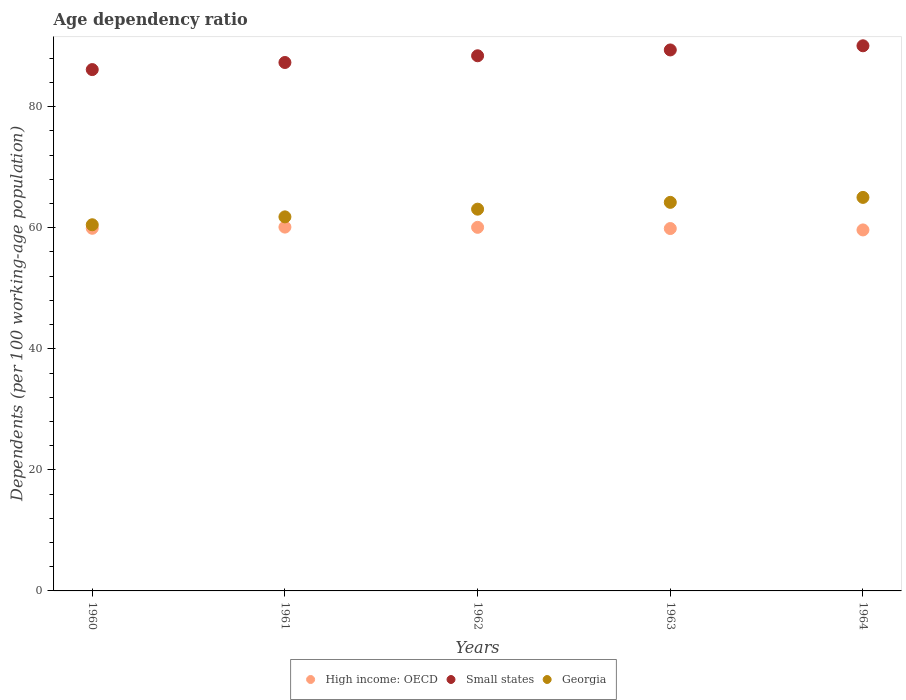Is the number of dotlines equal to the number of legend labels?
Your answer should be compact. Yes. What is the age dependency ratio in in Georgia in 1961?
Ensure brevity in your answer.  61.8. Across all years, what is the maximum age dependency ratio in in High income: OECD?
Offer a terse response. 60.11. Across all years, what is the minimum age dependency ratio in in Small states?
Your answer should be very brief. 86.14. In which year was the age dependency ratio in in Georgia maximum?
Ensure brevity in your answer.  1964. In which year was the age dependency ratio in in High income: OECD minimum?
Your response must be concise. 1964. What is the total age dependency ratio in in Small states in the graph?
Your answer should be very brief. 441.31. What is the difference between the age dependency ratio in in High income: OECD in 1963 and that in 1964?
Your answer should be compact. 0.23. What is the difference between the age dependency ratio in in Georgia in 1961 and the age dependency ratio in in Small states in 1964?
Your answer should be compact. -28.27. What is the average age dependency ratio in in Small states per year?
Offer a terse response. 88.26. In the year 1964, what is the difference between the age dependency ratio in in High income: OECD and age dependency ratio in in Small states?
Offer a very short reply. -30.43. What is the ratio of the age dependency ratio in in Small states in 1961 to that in 1962?
Keep it short and to the point. 0.99. What is the difference between the highest and the second highest age dependency ratio in in Small states?
Offer a terse response. 0.69. What is the difference between the highest and the lowest age dependency ratio in in High income: OECD?
Ensure brevity in your answer.  0.47. In how many years, is the age dependency ratio in in High income: OECD greater than the average age dependency ratio in in High income: OECD taken over all years?
Your answer should be very brief. 2. Is it the case that in every year, the sum of the age dependency ratio in in High income: OECD and age dependency ratio in in Small states  is greater than the age dependency ratio in in Georgia?
Your answer should be very brief. Yes. Is the age dependency ratio in in High income: OECD strictly less than the age dependency ratio in in Georgia over the years?
Your answer should be very brief. Yes. How many dotlines are there?
Provide a succinct answer. 3. How many years are there in the graph?
Your response must be concise. 5. What is the title of the graph?
Offer a terse response. Age dependency ratio. What is the label or title of the X-axis?
Your response must be concise. Years. What is the label or title of the Y-axis?
Offer a terse response. Dependents (per 100 working-age population). What is the Dependents (per 100 working-age population) in High income: OECD in 1960?
Keep it short and to the point. 59.92. What is the Dependents (per 100 working-age population) in Small states in 1960?
Give a very brief answer. 86.14. What is the Dependents (per 100 working-age population) of Georgia in 1960?
Your response must be concise. 60.5. What is the Dependents (per 100 working-age population) in High income: OECD in 1961?
Offer a terse response. 60.11. What is the Dependents (per 100 working-age population) of Small states in 1961?
Offer a terse response. 87.31. What is the Dependents (per 100 working-age population) of Georgia in 1961?
Keep it short and to the point. 61.8. What is the Dependents (per 100 working-age population) in High income: OECD in 1962?
Your answer should be very brief. 60.07. What is the Dependents (per 100 working-age population) of Small states in 1962?
Provide a succinct answer. 88.42. What is the Dependents (per 100 working-age population) of Georgia in 1962?
Make the answer very short. 63.07. What is the Dependents (per 100 working-age population) of High income: OECD in 1963?
Offer a very short reply. 59.87. What is the Dependents (per 100 working-age population) in Small states in 1963?
Give a very brief answer. 89.38. What is the Dependents (per 100 working-age population) in Georgia in 1963?
Your answer should be compact. 64.2. What is the Dependents (per 100 working-age population) in High income: OECD in 1964?
Make the answer very short. 59.64. What is the Dependents (per 100 working-age population) of Small states in 1964?
Offer a very short reply. 90.07. What is the Dependents (per 100 working-age population) of Georgia in 1964?
Provide a succinct answer. 65.02. Across all years, what is the maximum Dependents (per 100 working-age population) in High income: OECD?
Provide a succinct answer. 60.11. Across all years, what is the maximum Dependents (per 100 working-age population) in Small states?
Give a very brief answer. 90.07. Across all years, what is the maximum Dependents (per 100 working-age population) of Georgia?
Offer a terse response. 65.02. Across all years, what is the minimum Dependents (per 100 working-age population) in High income: OECD?
Make the answer very short. 59.64. Across all years, what is the minimum Dependents (per 100 working-age population) of Small states?
Your answer should be very brief. 86.14. Across all years, what is the minimum Dependents (per 100 working-age population) of Georgia?
Provide a succinct answer. 60.5. What is the total Dependents (per 100 working-age population) in High income: OECD in the graph?
Offer a terse response. 299.62. What is the total Dependents (per 100 working-age population) of Small states in the graph?
Your answer should be very brief. 441.31. What is the total Dependents (per 100 working-age population) of Georgia in the graph?
Your response must be concise. 314.59. What is the difference between the Dependents (per 100 working-age population) of High income: OECD in 1960 and that in 1961?
Offer a very short reply. -0.2. What is the difference between the Dependents (per 100 working-age population) in Small states in 1960 and that in 1961?
Keep it short and to the point. -1.17. What is the difference between the Dependents (per 100 working-age population) of Georgia in 1960 and that in 1961?
Offer a very short reply. -1.3. What is the difference between the Dependents (per 100 working-age population) in High income: OECD in 1960 and that in 1962?
Keep it short and to the point. -0.16. What is the difference between the Dependents (per 100 working-age population) of Small states in 1960 and that in 1962?
Your response must be concise. -2.28. What is the difference between the Dependents (per 100 working-age population) of Georgia in 1960 and that in 1962?
Your answer should be compact. -2.58. What is the difference between the Dependents (per 100 working-age population) in High income: OECD in 1960 and that in 1963?
Make the answer very short. 0.04. What is the difference between the Dependents (per 100 working-age population) of Small states in 1960 and that in 1963?
Offer a terse response. -3.25. What is the difference between the Dependents (per 100 working-age population) in Georgia in 1960 and that in 1963?
Your answer should be compact. -3.7. What is the difference between the Dependents (per 100 working-age population) of High income: OECD in 1960 and that in 1964?
Ensure brevity in your answer.  0.27. What is the difference between the Dependents (per 100 working-age population) in Small states in 1960 and that in 1964?
Keep it short and to the point. -3.93. What is the difference between the Dependents (per 100 working-age population) of Georgia in 1960 and that in 1964?
Your response must be concise. -4.52. What is the difference between the Dependents (per 100 working-age population) of High income: OECD in 1961 and that in 1962?
Make the answer very short. 0.04. What is the difference between the Dependents (per 100 working-age population) in Small states in 1961 and that in 1962?
Keep it short and to the point. -1.11. What is the difference between the Dependents (per 100 working-age population) in Georgia in 1961 and that in 1962?
Give a very brief answer. -1.27. What is the difference between the Dependents (per 100 working-age population) of High income: OECD in 1961 and that in 1963?
Provide a succinct answer. 0.24. What is the difference between the Dependents (per 100 working-age population) in Small states in 1961 and that in 1963?
Ensure brevity in your answer.  -2.07. What is the difference between the Dependents (per 100 working-age population) in Georgia in 1961 and that in 1963?
Offer a terse response. -2.4. What is the difference between the Dependents (per 100 working-age population) of High income: OECD in 1961 and that in 1964?
Keep it short and to the point. 0.47. What is the difference between the Dependents (per 100 working-age population) of Small states in 1961 and that in 1964?
Provide a short and direct response. -2.76. What is the difference between the Dependents (per 100 working-age population) in Georgia in 1961 and that in 1964?
Offer a very short reply. -3.22. What is the difference between the Dependents (per 100 working-age population) of High income: OECD in 1962 and that in 1963?
Ensure brevity in your answer.  0.2. What is the difference between the Dependents (per 100 working-age population) in Small states in 1962 and that in 1963?
Your answer should be very brief. -0.96. What is the difference between the Dependents (per 100 working-age population) in Georgia in 1962 and that in 1963?
Provide a succinct answer. -1.13. What is the difference between the Dependents (per 100 working-age population) of High income: OECD in 1962 and that in 1964?
Provide a succinct answer. 0.43. What is the difference between the Dependents (per 100 working-age population) of Small states in 1962 and that in 1964?
Your response must be concise. -1.65. What is the difference between the Dependents (per 100 working-age population) of Georgia in 1962 and that in 1964?
Provide a succinct answer. -1.94. What is the difference between the Dependents (per 100 working-age population) in High income: OECD in 1963 and that in 1964?
Make the answer very short. 0.23. What is the difference between the Dependents (per 100 working-age population) in Small states in 1963 and that in 1964?
Provide a succinct answer. -0.69. What is the difference between the Dependents (per 100 working-age population) of Georgia in 1963 and that in 1964?
Keep it short and to the point. -0.82. What is the difference between the Dependents (per 100 working-age population) in High income: OECD in 1960 and the Dependents (per 100 working-age population) in Small states in 1961?
Your response must be concise. -27.39. What is the difference between the Dependents (per 100 working-age population) in High income: OECD in 1960 and the Dependents (per 100 working-age population) in Georgia in 1961?
Offer a very short reply. -1.89. What is the difference between the Dependents (per 100 working-age population) in Small states in 1960 and the Dependents (per 100 working-age population) in Georgia in 1961?
Keep it short and to the point. 24.33. What is the difference between the Dependents (per 100 working-age population) in High income: OECD in 1960 and the Dependents (per 100 working-age population) in Small states in 1962?
Keep it short and to the point. -28.5. What is the difference between the Dependents (per 100 working-age population) in High income: OECD in 1960 and the Dependents (per 100 working-age population) in Georgia in 1962?
Make the answer very short. -3.16. What is the difference between the Dependents (per 100 working-age population) of Small states in 1960 and the Dependents (per 100 working-age population) of Georgia in 1962?
Your answer should be compact. 23.06. What is the difference between the Dependents (per 100 working-age population) in High income: OECD in 1960 and the Dependents (per 100 working-age population) in Small states in 1963?
Keep it short and to the point. -29.47. What is the difference between the Dependents (per 100 working-age population) in High income: OECD in 1960 and the Dependents (per 100 working-age population) in Georgia in 1963?
Keep it short and to the point. -4.28. What is the difference between the Dependents (per 100 working-age population) of Small states in 1960 and the Dependents (per 100 working-age population) of Georgia in 1963?
Give a very brief answer. 21.94. What is the difference between the Dependents (per 100 working-age population) in High income: OECD in 1960 and the Dependents (per 100 working-age population) in Small states in 1964?
Make the answer very short. -30.15. What is the difference between the Dependents (per 100 working-age population) in High income: OECD in 1960 and the Dependents (per 100 working-age population) in Georgia in 1964?
Provide a succinct answer. -5.1. What is the difference between the Dependents (per 100 working-age population) of Small states in 1960 and the Dependents (per 100 working-age population) of Georgia in 1964?
Ensure brevity in your answer.  21.12. What is the difference between the Dependents (per 100 working-age population) of High income: OECD in 1961 and the Dependents (per 100 working-age population) of Small states in 1962?
Give a very brief answer. -28.31. What is the difference between the Dependents (per 100 working-age population) of High income: OECD in 1961 and the Dependents (per 100 working-age population) of Georgia in 1962?
Your answer should be compact. -2.96. What is the difference between the Dependents (per 100 working-age population) of Small states in 1961 and the Dependents (per 100 working-age population) of Georgia in 1962?
Give a very brief answer. 24.23. What is the difference between the Dependents (per 100 working-age population) of High income: OECD in 1961 and the Dependents (per 100 working-age population) of Small states in 1963?
Your answer should be compact. -29.27. What is the difference between the Dependents (per 100 working-age population) of High income: OECD in 1961 and the Dependents (per 100 working-age population) of Georgia in 1963?
Make the answer very short. -4.09. What is the difference between the Dependents (per 100 working-age population) of Small states in 1961 and the Dependents (per 100 working-age population) of Georgia in 1963?
Your response must be concise. 23.11. What is the difference between the Dependents (per 100 working-age population) of High income: OECD in 1961 and the Dependents (per 100 working-age population) of Small states in 1964?
Your answer should be very brief. -29.96. What is the difference between the Dependents (per 100 working-age population) of High income: OECD in 1961 and the Dependents (per 100 working-age population) of Georgia in 1964?
Give a very brief answer. -4.91. What is the difference between the Dependents (per 100 working-age population) in Small states in 1961 and the Dependents (per 100 working-age population) in Georgia in 1964?
Your answer should be very brief. 22.29. What is the difference between the Dependents (per 100 working-age population) in High income: OECD in 1962 and the Dependents (per 100 working-age population) in Small states in 1963?
Offer a very short reply. -29.31. What is the difference between the Dependents (per 100 working-age population) of High income: OECD in 1962 and the Dependents (per 100 working-age population) of Georgia in 1963?
Give a very brief answer. -4.13. What is the difference between the Dependents (per 100 working-age population) of Small states in 1962 and the Dependents (per 100 working-age population) of Georgia in 1963?
Give a very brief answer. 24.22. What is the difference between the Dependents (per 100 working-age population) in High income: OECD in 1962 and the Dependents (per 100 working-age population) in Small states in 1964?
Keep it short and to the point. -30. What is the difference between the Dependents (per 100 working-age population) of High income: OECD in 1962 and the Dependents (per 100 working-age population) of Georgia in 1964?
Provide a short and direct response. -4.94. What is the difference between the Dependents (per 100 working-age population) of Small states in 1962 and the Dependents (per 100 working-age population) of Georgia in 1964?
Keep it short and to the point. 23.4. What is the difference between the Dependents (per 100 working-age population) in High income: OECD in 1963 and the Dependents (per 100 working-age population) in Small states in 1964?
Your answer should be compact. -30.2. What is the difference between the Dependents (per 100 working-age population) in High income: OECD in 1963 and the Dependents (per 100 working-age population) in Georgia in 1964?
Offer a very short reply. -5.14. What is the difference between the Dependents (per 100 working-age population) of Small states in 1963 and the Dependents (per 100 working-age population) of Georgia in 1964?
Give a very brief answer. 24.36. What is the average Dependents (per 100 working-age population) in High income: OECD per year?
Give a very brief answer. 59.92. What is the average Dependents (per 100 working-age population) in Small states per year?
Your answer should be compact. 88.26. What is the average Dependents (per 100 working-age population) in Georgia per year?
Provide a short and direct response. 62.92. In the year 1960, what is the difference between the Dependents (per 100 working-age population) in High income: OECD and Dependents (per 100 working-age population) in Small states?
Keep it short and to the point. -26.22. In the year 1960, what is the difference between the Dependents (per 100 working-age population) in High income: OECD and Dependents (per 100 working-age population) in Georgia?
Your response must be concise. -0.58. In the year 1960, what is the difference between the Dependents (per 100 working-age population) of Small states and Dependents (per 100 working-age population) of Georgia?
Ensure brevity in your answer.  25.64. In the year 1961, what is the difference between the Dependents (per 100 working-age population) of High income: OECD and Dependents (per 100 working-age population) of Small states?
Give a very brief answer. -27.2. In the year 1961, what is the difference between the Dependents (per 100 working-age population) in High income: OECD and Dependents (per 100 working-age population) in Georgia?
Ensure brevity in your answer.  -1.69. In the year 1961, what is the difference between the Dependents (per 100 working-age population) in Small states and Dependents (per 100 working-age population) in Georgia?
Keep it short and to the point. 25.51. In the year 1962, what is the difference between the Dependents (per 100 working-age population) of High income: OECD and Dependents (per 100 working-age population) of Small states?
Give a very brief answer. -28.35. In the year 1962, what is the difference between the Dependents (per 100 working-age population) in High income: OECD and Dependents (per 100 working-age population) in Georgia?
Ensure brevity in your answer.  -3. In the year 1962, what is the difference between the Dependents (per 100 working-age population) in Small states and Dependents (per 100 working-age population) in Georgia?
Provide a succinct answer. 25.35. In the year 1963, what is the difference between the Dependents (per 100 working-age population) in High income: OECD and Dependents (per 100 working-age population) in Small states?
Provide a succinct answer. -29.51. In the year 1963, what is the difference between the Dependents (per 100 working-age population) of High income: OECD and Dependents (per 100 working-age population) of Georgia?
Your response must be concise. -4.33. In the year 1963, what is the difference between the Dependents (per 100 working-age population) in Small states and Dependents (per 100 working-age population) in Georgia?
Provide a short and direct response. 25.18. In the year 1964, what is the difference between the Dependents (per 100 working-age population) of High income: OECD and Dependents (per 100 working-age population) of Small states?
Provide a short and direct response. -30.43. In the year 1964, what is the difference between the Dependents (per 100 working-age population) of High income: OECD and Dependents (per 100 working-age population) of Georgia?
Make the answer very short. -5.37. In the year 1964, what is the difference between the Dependents (per 100 working-age population) in Small states and Dependents (per 100 working-age population) in Georgia?
Provide a short and direct response. 25.05. What is the ratio of the Dependents (per 100 working-age population) of High income: OECD in 1960 to that in 1961?
Ensure brevity in your answer.  1. What is the ratio of the Dependents (per 100 working-age population) in Small states in 1960 to that in 1961?
Your answer should be very brief. 0.99. What is the ratio of the Dependents (per 100 working-age population) in Georgia in 1960 to that in 1961?
Your response must be concise. 0.98. What is the ratio of the Dependents (per 100 working-age population) of High income: OECD in 1960 to that in 1962?
Provide a succinct answer. 1. What is the ratio of the Dependents (per 100 working-age population) in Small states in 1960 to that in 1962?
Your response must be concise. 0.97. What is the ratio of the Dependents (per 100 working-age population) of Georgia in 1960 to that in 1962?
Make the answer very short. 0.96. What is the ratio of the Dependents (per 100 working-age population) in High income: OECD in 1960 to that in 1963?
Provide a short and direct response. 1. What is the ratio of the Dependents (per 100 working-age population) in Small states in 1960 to that in 1963?
Ensure brevity in your answer.  0.96. What is the ratio of the Dependents (per 100 working-age population) of Georgia in 1960 to that in 1963?
Ensure brevity in your answer.  0.94. What is the ratio of the Dependents (per 100 working-age population) of Small states in 1960 to that in 1964?
Your response must be concise. 0.96. What is the ratio of the Dependents (per 100 working-age population) in Georgia in 1960 to that in 1964?
Offer a very short reply. 0.93. What is the ratio of the Dependents (per 100 working-age population) of High income: OECD in 1961 to that in 1962?
Offer a very short reply. 1. What is the ratio of the Dependents (per 100 working-age population) of Small states in 1961 to that in 1962?
Make the answer very short. 0.99. What is the ratio of the Dependents (per 100 working-age population) in Georgia in 1961 to that in 1962?
Your answer should be compact. 0.98. What is the ratio of the Dependents (per 100 working-age population) of Small states in 1961 to that in 1963?
Offer a very short reply. 0.98. What is the ratio of the Dependents (per 100 working-age population) in Georgia in 1961 to that in 1963?
Your answer should be very brief. 0.96. What is the ratio of the Dependents (per 100 working-age population) of High income: OECD in 1961 to that in 1964?
Offer a terse response. 1.01. What is the ratio of the Dependents (per 100 working-age population) of Small states in 1961 to that in 1964?
Your answer should be compact. 0.97. What is the ratio of the Dependents (per 100 working-age population) of Georgia in 1961 to that in 1964?
Give a very brief answer. 0.95. What is the ratio of the Dependents (per 100 working-age population) of High income: OECD in 1962 to that in 1963?
Keep it short and to the point. 1. What is the ratio of the Dependents (per 100 working-age population) in Small states in 1962 to that in 1963?
Provide a succinct answer. 0.99. What is the ratio of the Dependents (per 100 working-age population) of Georgia in 1962 to that in 1963?
Provide a short and direct response. 0.98. What is the ratio of the Dependents (per 100 working-age population) in High income: OECD in 1962 to that in 1964?
Keep it short and to the point. 1.01. What is the ratio of the Dependents (per 100 working-age population) of Small states in 1962 to that in 1964?
Give a very brief answer. 0.98. What is the ratio of the Dependents (per 100 working-age population) in Georgia in 1962 to that in 1964?
Offer a terse response. 0.97. What is the ratio of the Dependents (per 100 working-age population) of Small states in 1963 to that in 1964?
Provide a succinct answer. 0.99. What is the ratio of the Dependents (per 100 working-age population) in Georgia in 1963 to that in 1964?
Offer a terse response. 0.99. What is the difference between the highest and the second highest Dependents (per 100 working-age population) of High income: OECD?
Give a very brief answer. 0.04. What is the difference between the highest and the second highest Dependents (per 100 working-age population) in Small states?
Provide a short and direct response. 0.69. What is the difference between the highest and the second highest Dependents (per 100 working-age population) of Georgia?
Provide a short and direct response. 0.82. What is the difference between the highest and the lowest Dependents (per 100 working-age population) of High income: OECD?
Offer a terse response. 0.47. What is the difference between the highest and the lowest Dependents (per 100 working-age population) of Small states?
Give a very brief answer. 3.93. What is the difference between the highest and the lowest Dependents (per 100 working-age population) of Georgia?
Offer a very short reply. 4.52. 